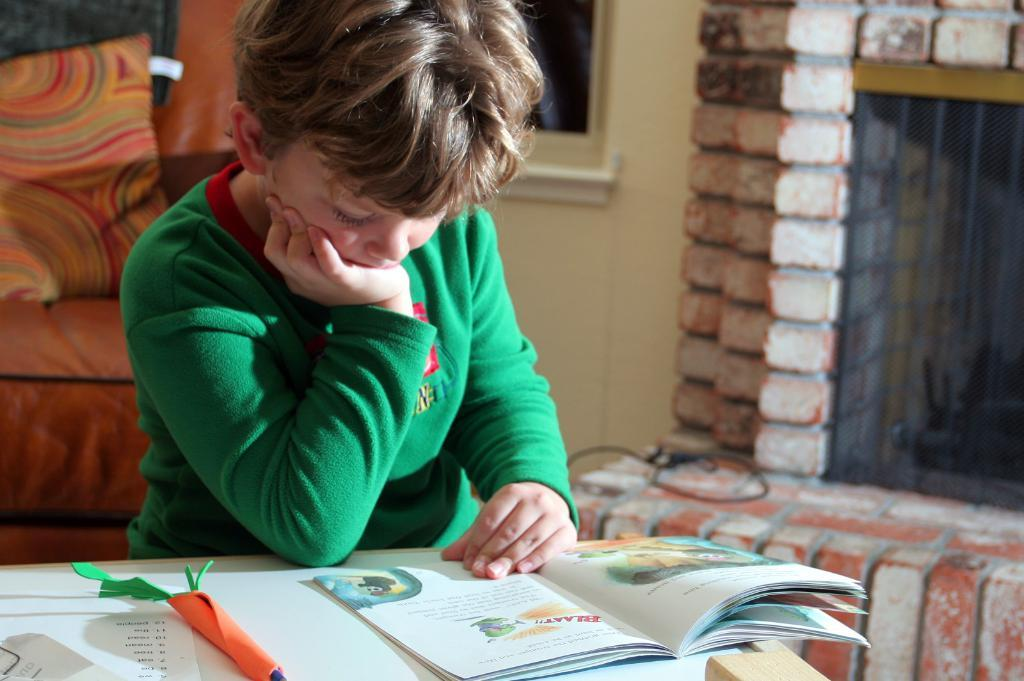<image>
Offer a succinct explanation of the picture presented. A boy reading a book that says "Blaat" on top in red. 